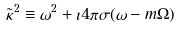<formula> <loc_0><loc_0><loc_500><loc_500>\tilde { \kappa } ^ { 2 } \equiv \omega ^ { 2 } + \imath 4 \pi \sigma ( \omega - m \Omega )</formula> 